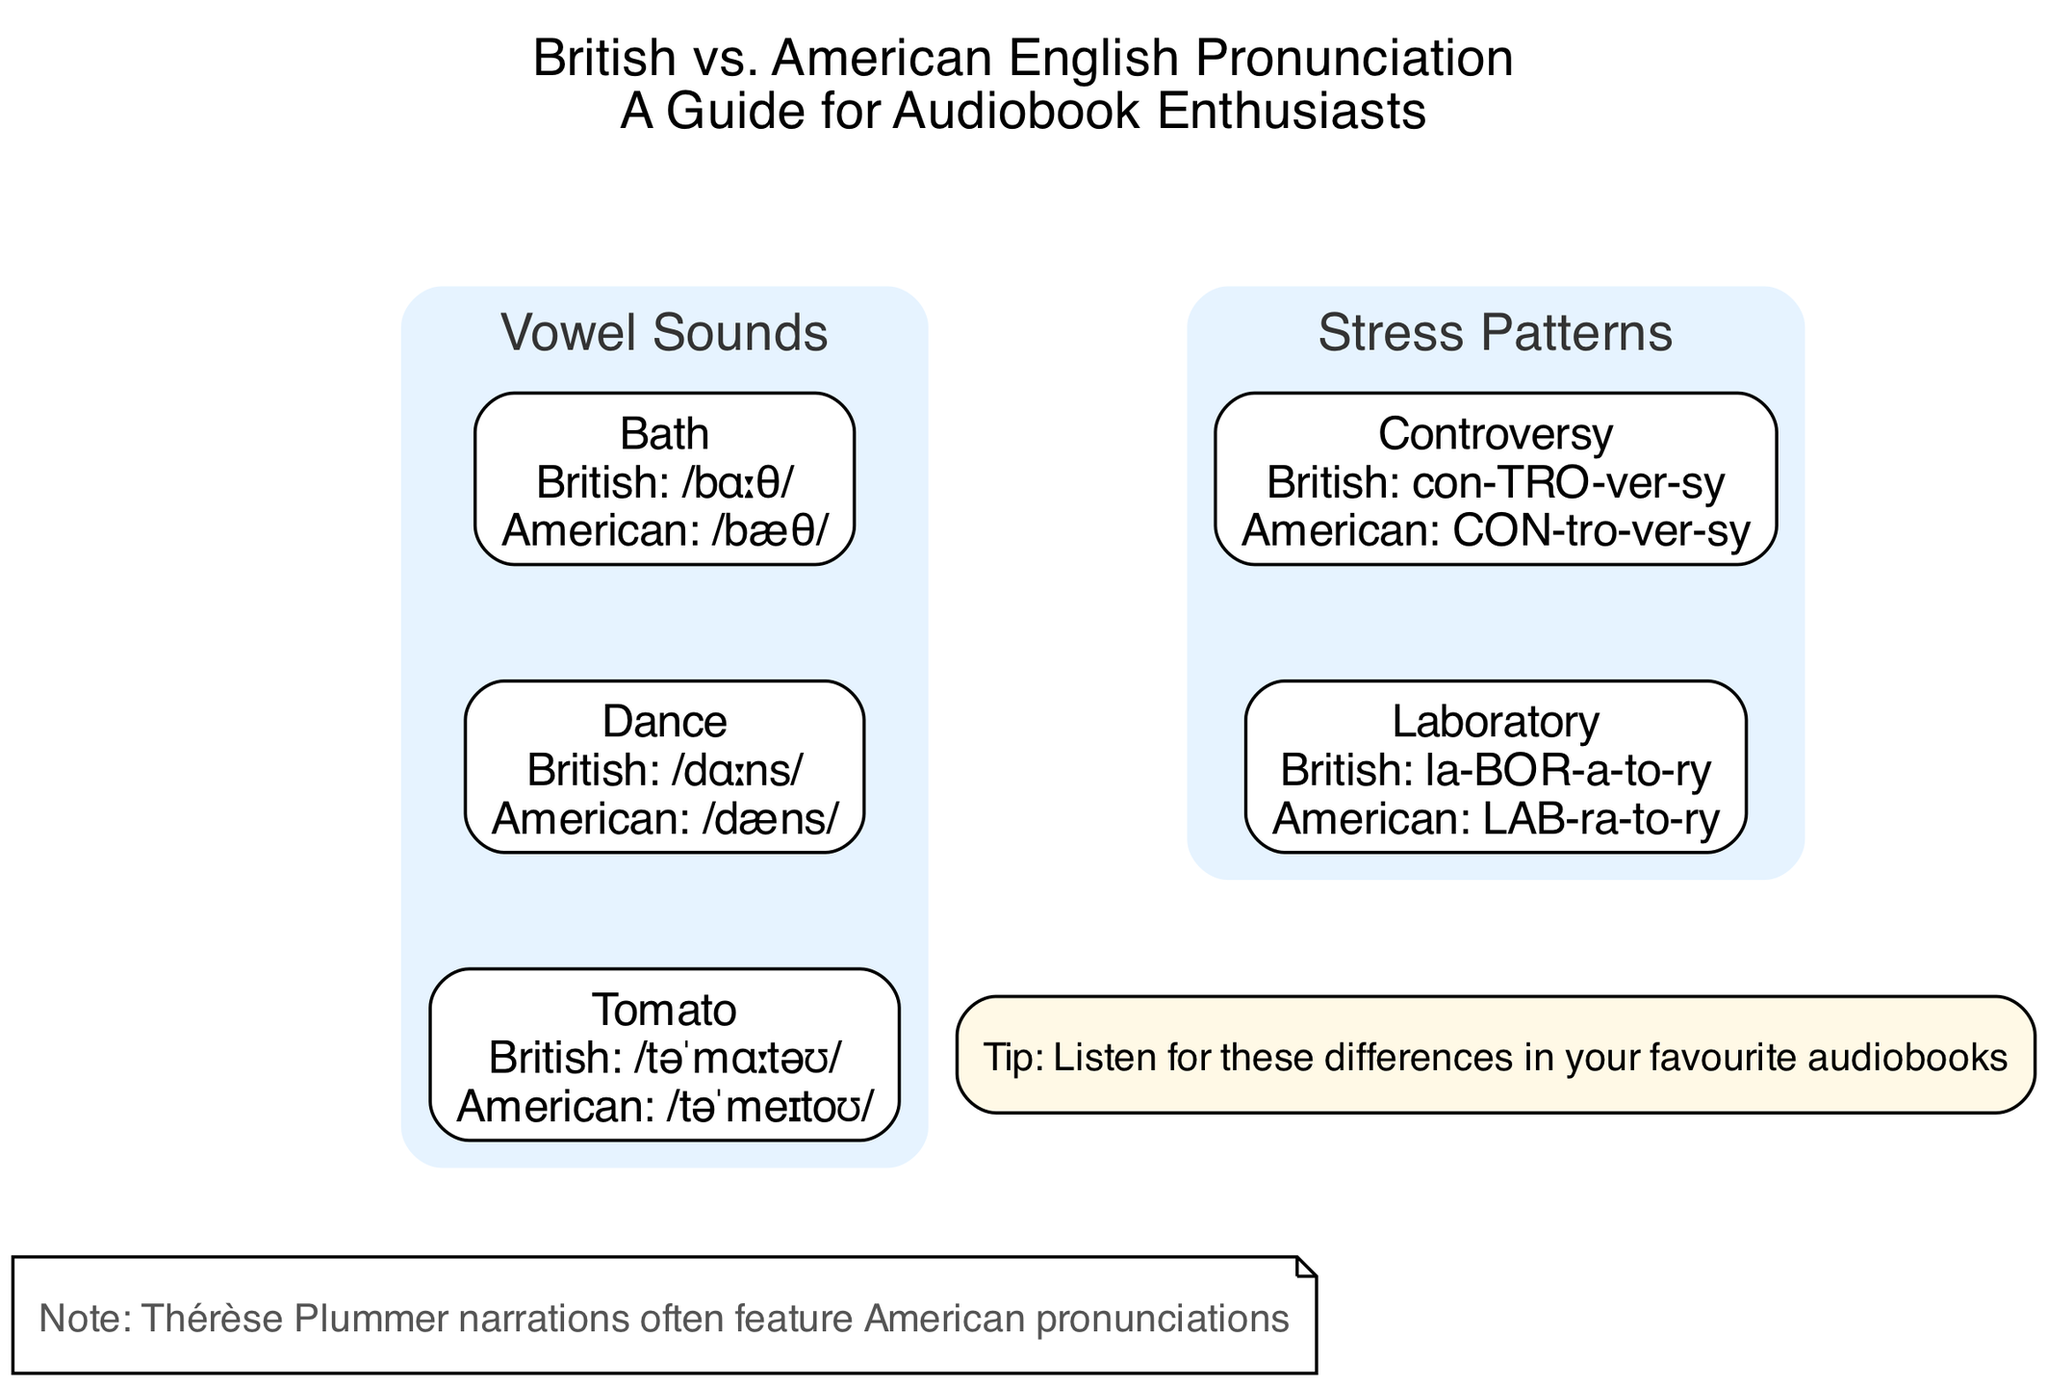What is the British pronunciation of "Bath"? The diagram directly shows the British pronunciation of "Bath" as "/bɑːθ/".
Answer: /bɑːθ/ How many vowel sounds are compared in the diagram? The diagram lists three words under the "Vowel Sounds" section, which means three vowel sounds are compared.
Answer: 3 What is the American pronunciation of "Dance"? The American pronunciation for "Dance" is indicated in the diagram as "/dæns/".
Answer: /dæns/ Which word has a different stress pattern between British and American English? The diagram indicates that "Controversy" has a different stress pattern, with British stressing the second syllable and American stressing the first.
Answer: Controversy What is the British pronunciation of "Tomato"? The British pronunciation shown for "Tomato" in the diagram is "/təˈmɑːtəʊ/".
Answer: /təˈmɑːtəʊ/ What shape is used for the "Note" section in the diagram? The diagram specifies that the "Note" section is represented using a note shape.
Answer: note How is the word "Laboratory" stressed in American English? According to the diagram, the American pronunciation of "Laboratory" stresses the first syllable, represented as "LAB-ra-to-ry".
Answer: LAB-ra-to-ry Which section contains the comparison for the word "Dance"? The diagram shows the word "Dance" under the "Vowel Sounds" section.
Answer: Vowel Sounds In total, how many stress pattern comparisons are listed? The diagram provides a total of two comparisons under the "Stress Patterns" section.
Answer: 2 